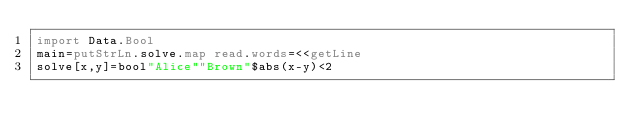<code> <loc_0><loc_0><loc_500><loc_500><_Haskell_>import Data.Bool
main=putStrLn.solve.map read.words=<<getLine
solve[x,y]=bool"Alice""Brown"$abs(x-y)<2</code> 